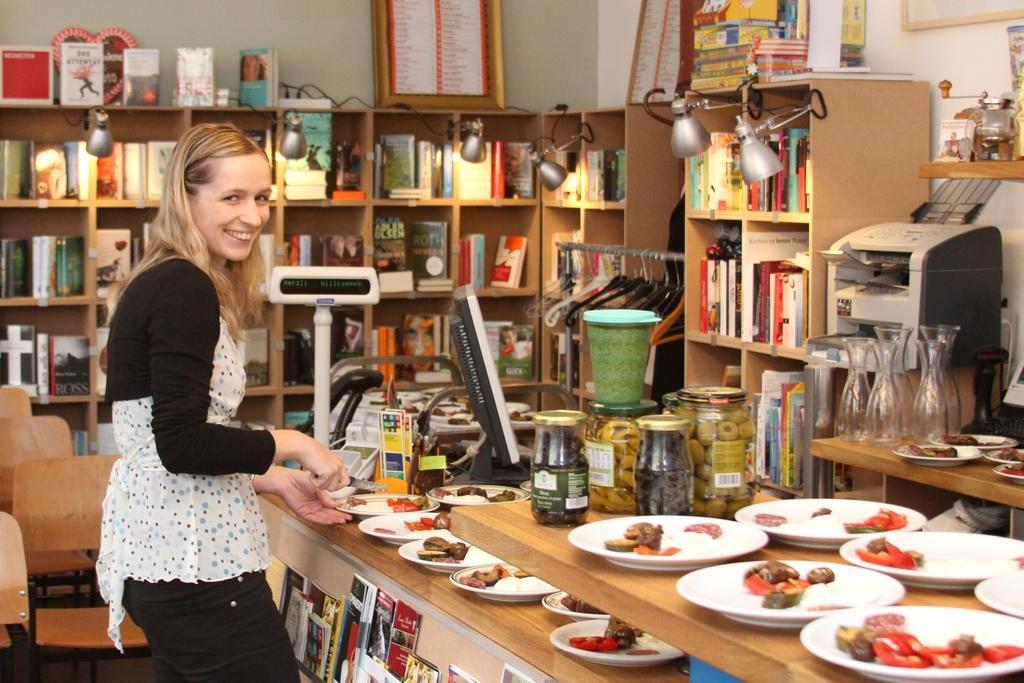Please provide a concise description of this image. This is a woman standing and smiling. This is a table with plates,jars,and a monitor placed on it. These are the books. This looks like a printer. this is a bookshelf with books in it. These are the hangers. This is a frame kept at the top of the rack. 